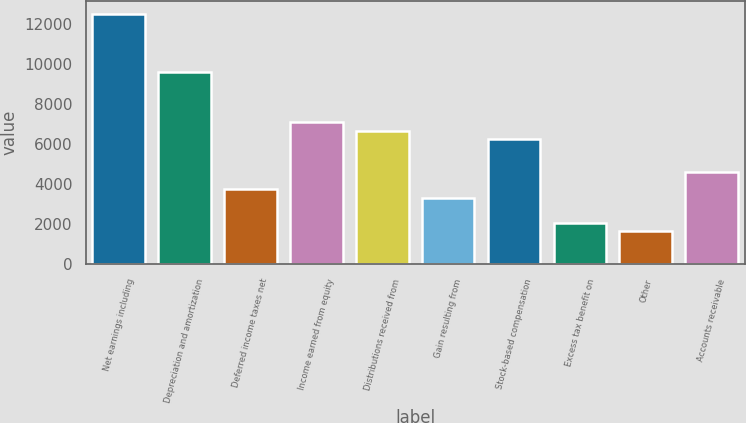Convert chart to OTSL. <chart><loc_0><loc_0><loc_500><loc_500><bar_chart><fcel>Net earnings including<fcel>Depreciation and amortization<fcel>Deferred income taxes net<fcel>Income earned from equity<fcel>Distributions received from<fcel>Gain resulting from<fcel>Stock-based compensation<fcel>Excess tax benefit on<fcel>Other<fcel>Accounts receivable<nl><fcel>12513.5<fcel>9594.78<fcel>3757.34<fcel>7093.02<fcel>6676.06<fcel>3340.38<fcel>6259.1<fcel>2089.5<fcel>1672.54<fcel>4591.26<nl></chart> 